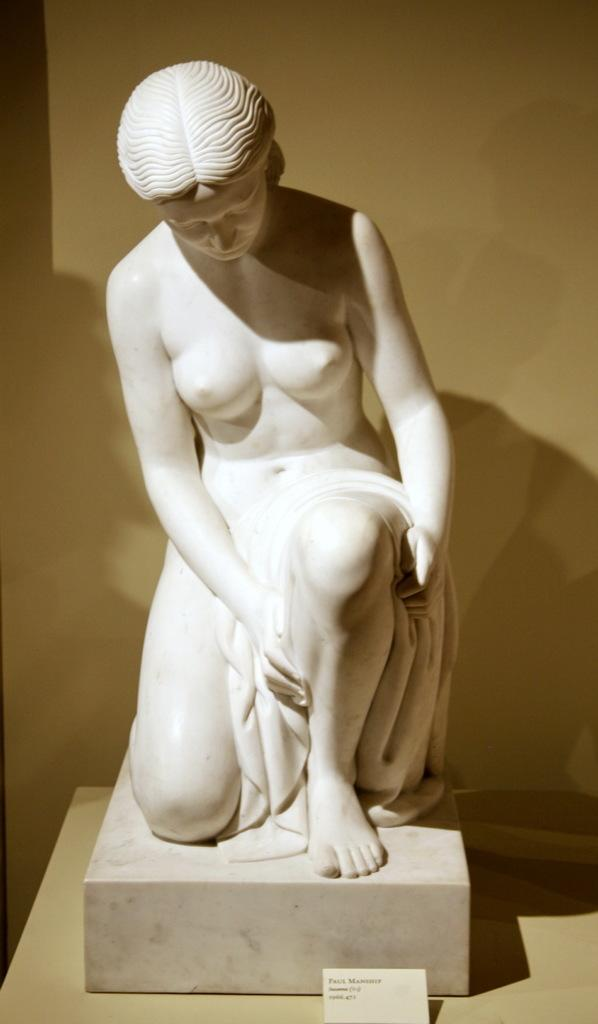What is the main subject in the middle of the picture? There is a statue in the middle of the picture. What can be seen in the background of the picture? There is a wall in the background of the picture. How many pets are visible in the crowd surrounding the statue? There is no crowd or pets present in the image; it features a statue and a wall in the background. 